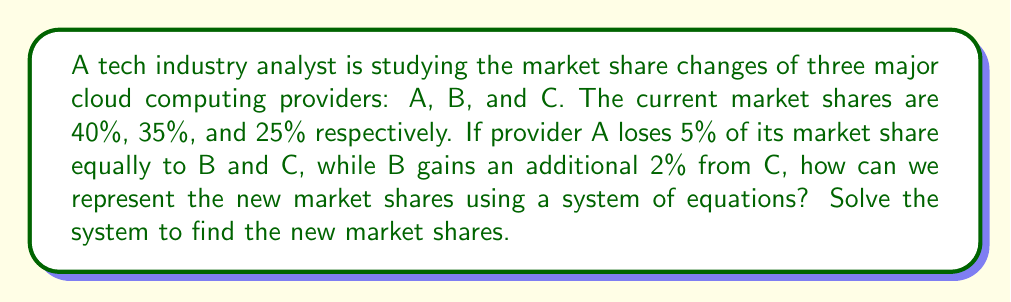Teach me how to tackle this problem. Let's approach this step-by-step:

1) Let $x$, $y$, and $z$ represent the new market shares of A, B, and C respectively.

2) We can set up three equations based on the given information:

   Equation 1: $x + y + z = 100$ (total market share must equal 100%)
   
   Equation 2: $x = 40 - 5 = 35$ (A loses 5% of its share)
   
   Equation 3: $y = 35 + 2.5 + 2 = 39.5$ (B gains 2.5% from A and 2% from C)

3) We now have a system of equations:

   $$\begin{cases}
   x + y + z = 100 \\
   x = 35 \\
   y = 39.5
   \end{cases}$$

4) We can solve this system by substitution:

   Substitute $x = 35$ and $y = 39.5$ into the first equation:

   $35 + 39.5 + z = 100$

5) Solve for $z$:

   $z = 100 - 35 - 39.5 = 25.5$

Therefore, the new market shares are:
A: 35%
B: 39.5%
C: 25.5%
Answer: A: 35%, B: 39.5%, C: 25.5% 